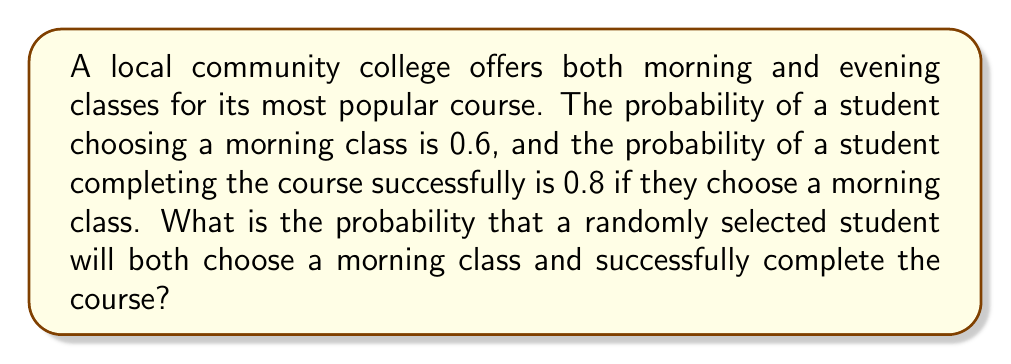Show me your answer to this math problem. Let's approach this step-by-step using the multiplication rule for compound events:

1) We need to find the probability of two events occurring together:
   A: The student chooses a morning class
   B: The student successfully completes the course

2) We're given:
   P(A) = 0.6 (probability of choosing a morning class)
   P(B|A) = 0.8 (probability of successfully completing the course, given that it's a morning class)

3) The multiplication rule for compound events states:
   P(A and B) = P(A) × P(B|A)

4) Let's substitute our values:
   P(A and B) = 0.6 × 0.8

5) Now we can calculate:
   P(A and B) = 0.6 × 0.8 = 0.48

Therefore, the probability that a randomly selected student will both choose a morning class and successfully complete the course is 0.48 or 48%.
Answer: 0.48 